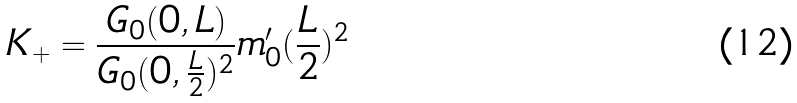<formula> <loc_0><loc_0><loc_500><loc_500>K _ { + } = \frac { G _ { 0 } ( 0 , L ) } { G _ { 0 } ( 0 , \frac { L } { 2 } ) ^ { 2 } } m ^ { \prime } _ { 0 } ( \frac { L } { 2 } ) ^ { 2 }</formula> 